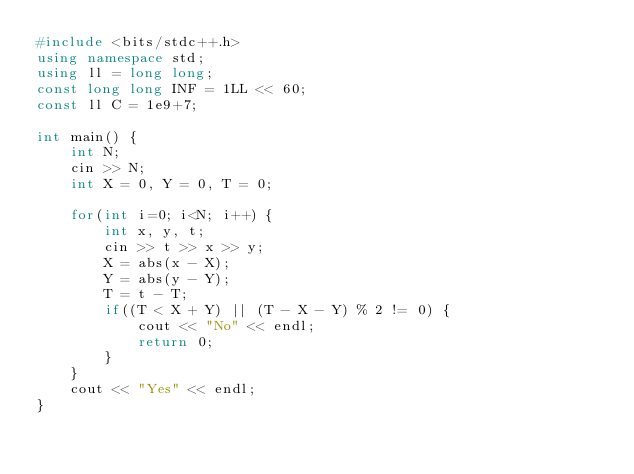Convert code to text. <code><loc_0><loc_0><loc_500><loc_500><_C++_>#include <bits/stdc++.h>
using namespace std;
using ll = long long;
const long long INF = 1LL << 60;
const ll C = 1e9+7;

int main() {
    int N;
    cin >> N;
    int X = 0, Y = 0, T = 0;

    for(int i=0; i<N; i++) {
        int x, y, t;
        cin >> t >> x >> y;
        X = abs(x - X);
        Y = abs(y - Y);
        T = t - T;
        if((T < X + Y) || (T - X - Y) % 2 != 0) {
            cout << "No" << endl;
            return 0;
        }
    }
    cout << "Yes" << endl;
}</code> 